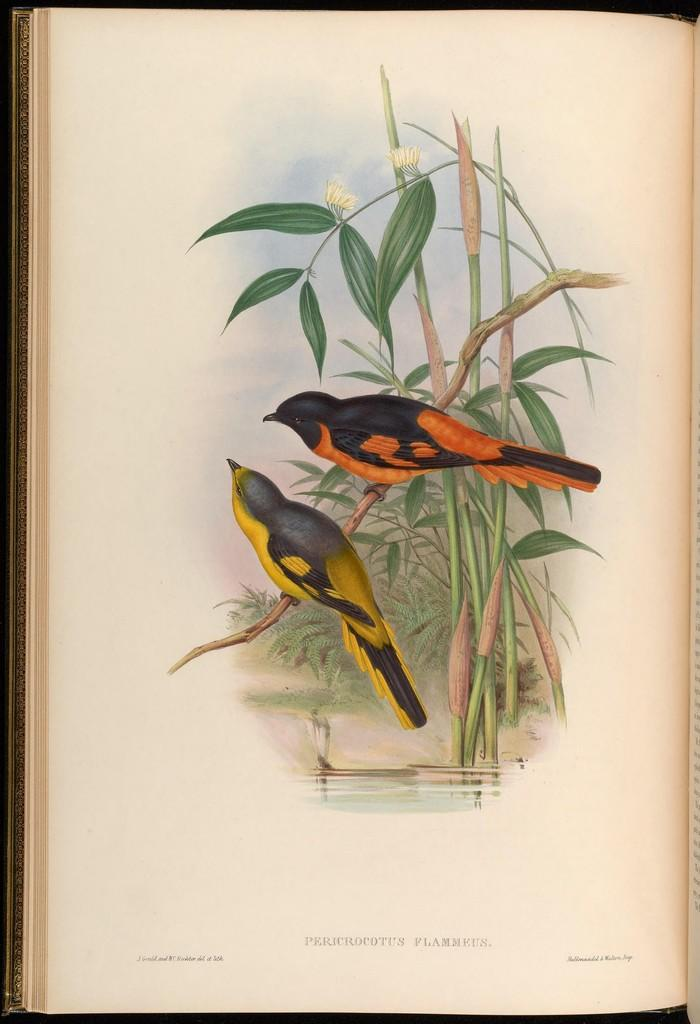What is the main object in the image? There is a book in the image. What is depicted on the book's cover? The book has a picture of two birds. What are the birds doing in the image? The birds are standing on the stem of a plant. What can be seen at the bottom of the image? There is water at the bottom of the image. What type of soap is being used to clean the grass in the image? There is no soap or grass present in the image. How is the hammer being used in the image? There is no hammer present in the image. 